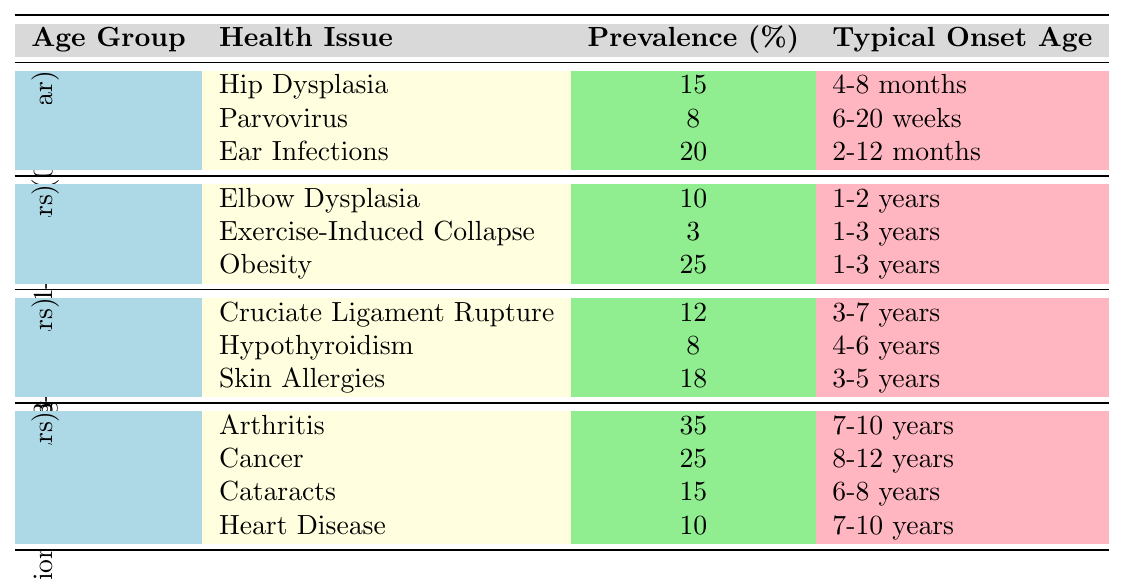What is the most common health issue in Senior (7+ years) Labrador Retrievers? The table shows that the most common health issue in the Senior age group is Arthritis, with a prevalence of 35%.
Answer: Arthritis How many health issues are listed for Young Adult (1-3 years) Labrador Retrievers? There are three health issues listed for the Young Adult age group: Elbow Dysplasia, Exercise-Induced Collapse, and Obesity.
Answer: Three What is the prevalence of Obesity in Young Adult (1-3 years) Labrador Retrievers? According to the table, the prevalence of Obesity in this age group is 25%.
Answer: 25% Is it true that Ear Infections have a higher prevalence than Parvovirus in puppies? Yes, the prevalence of Ear Infections is 20%, which is higher than the 8% prevalence for Parvovirus in puppies.
Answer: Yes What are the typical onset ages for health issues in Adult (3-7 years) Labrador Retrievers? The typical onset ages for adult health issues are as follows: Cruciate Ligament Rupture (3-7 years), Hypothyroidism (4-6 years), and Skin Allergies (3-5 years).
Answer: 3-7 years, 4-6 years, 3-5 years What is the total prevalence percentage of health issues listed for Puppy (0-1 year) Labrador Retrievers? The total prevalence percentage can be calculated by adding Hip Dysplasia (15%), Parvovirus (8%), and Ear Infections (20%), resulting in 15 + 8 + 20 = 43%.
Answer: 43% Which health issue among Senior (7+ years) Labradors has a typical onset of 7-10 years? Heart Disease is the health issue with a typical onset of 7-10 years listed for Senior Labradors.
Answer: Heart Disease How does the prevalence of Cancer in Senior (7+ years) compare to that of Hip Dysplasia in Puppies (0-1 year)? The prevalence of Cancer in Senior Labradors is 25%, while Hip Dysplasia in Puppies is at 15%. Therefore, Cancer is more prevalent than Hip Dysplasia by 10%.
Answer: Cancer is more prevalent What health issue has the lowest prevalence among Young Adult (1-3 years) Labrador Retrievers? Exercise-Induced Collapse has the lowest prevalence of 3% among the health issues in the Young Adult group.
Answer: Exercise-Induced Collapse What is the prevalence of Skin Allergies in Adult (3-7 years)? Skin Allergies have a prevalence of 18% in the Adult age group.
Answer: 18% Which age group is most likely to experience health issues related to Arthritis? The Senior (7+ years) age group is most likely to experience Arthritis, with a prevalence of 35%.
Answer: Senior (7+ years) 